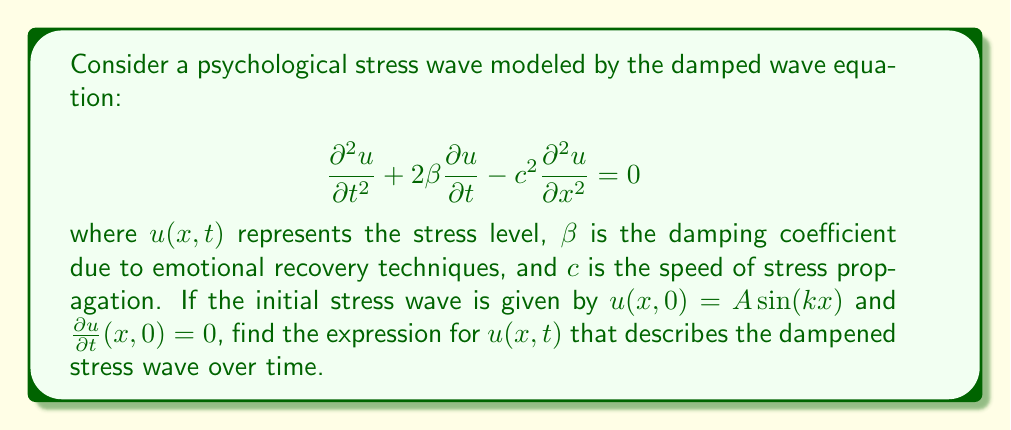Can you answer this question? To solve this damped wave equation, we'll follow these steps:

1) Assume a solution of the form: $u(x,t) = X(x)T(t)$

2) Substituting this into the wave equation:

   $$X\frac{d^2T}{dt^2} + 2\beta X\frac{dT}{dt} - c^2T\frac{d^2X}{dx^2} = 0$$

3) Dividing by $XT$:

   $$\frac{1}{T}\frac{d^2T}{dt^2} + \frac{2\beta}{T}\frac{dT}{dt} = \frac{c^2}{X}\frac{d^2X}{dx^2} = -\omega^2$$

   Where $-\omega^2$ is the separation constant.

4) This gives us two equations:
   
   For $X$: $\frac{d^2X}{dx^2} + \frac{\omega^2}{c^2}X = 0$
   
   For $T$: $\frac{d^2T}{dt^2} + 2\beta\frac{dT}{dt} + \omega^2T = 0$

5) The solution for $X$ is: $X(x) = A\sin(kx)$, where $k = \frac{\omega}{c}$

6) For $T$, we have a characteristic equation: $r^2 + 2\beta r + \omega^2 = 0$

   With roots: $r = -\beta \pm \sqrt{\beta^2 - \omega^2}$

7) If $\beta^2 < \omega^2$ (underdamped case), the solution for $T$ is:

   $$T(t) = e^{-\beta t}(B\cos(\sqrt{\omega^2-\beta^2}t) + C\sin(\sqrt{\omega^2-\beta^2}t))$$

8) Combining $X$ and $T$:

   $$u(x,t) = Ae^{-\beta t}\sin(kx)(B\cos(\sqrt{\omega^2-\beta^2}t) + C\sin(\sqrt{\omega^2-\beta^2}t))$$

9) Using the initial conditions:
   
   $u(x,0) = A\sin(kx)$ implies $B = 1$
   
   $\frac{\partial u}{\partial t}(x,0) = 0$ implies $C = \frac{\beta}{\sqrt{\omega^2-\beta^2}}$

10) Therefore, the final solution is:

    $$u(x,t) = Ae^{-\beta t}\sin(kx)(\cos(\sqrt{\omega^2-\beta^2}t) + \frac{\beta}{\sqrt{\omega^2-\beta^2}}\sin(\sqrt{\omega^2-\beta^2}t))$$

Where $\omega = kc$.
Answer: $u(x,t) = Ae^{-\beta t}\sin(kx)(\cos(\sqrt{k^2c^2-\beta^2}t) + \frac{\beta}{\sqrt{k^2c^2-\beta^2}}\sin(\sqrt{k^2c^2-\beta^2}t))$ 